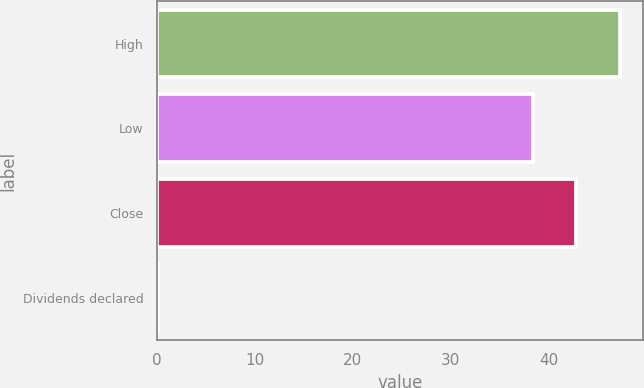Convert chart. <chart><loc_0><loc_0><loc_500><loc_500><bar_chart><fcel>High<fcel>Low<fcel>Close<fcel>Dividends declared<nl><fcel>47.23<fcel>38.39<fcel>42.81<fcel>0.13<nl></chart> 